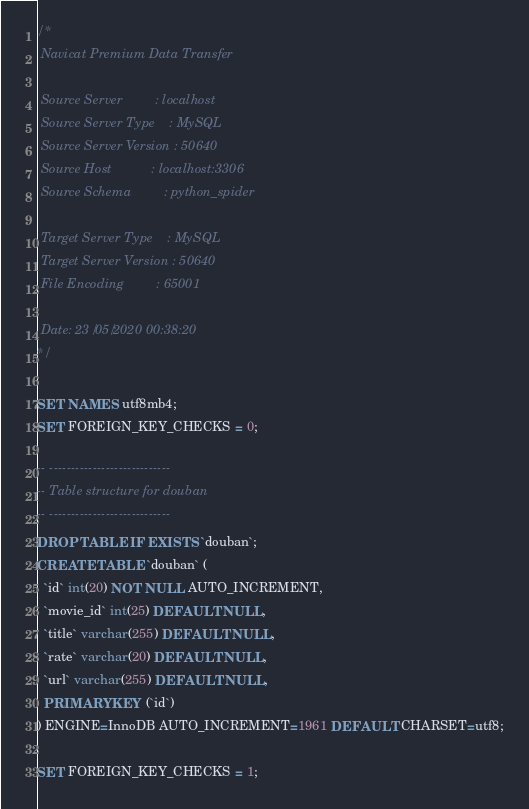Convert code to text. <code><loc_0><loc_0><loc_500><loc_500><_SQL_>/*
 Navicat Premium Data Transfer

 Source Server         : localhost
 Source Server Type    : MySQL
 Source Server Version : 50640
 Source Host           : localhost:3306
 Source Schema         : python_spider

 Target Server Type    : MySQL
 Target Server Version : 50640
 File Encoding         : 65001

 Date: 23/05/2020 00:38:20
*/

SET NAMES utf8mb4;
SET FOREIGN_KEY_CHECKS = 0;

-- ----------------------------
-- Table structure for douban
-- ----------------------------
DROP TABLE IF EXISTS `douban`;
CREATE TABLE `douban` (
  `id` int(20) NOT NULL AUTO_INCREMENT,
  `movie_id` int(25) DEFAULT NULL,
  `title` varchar(255) DEFAULT NULL,
  `rate` varchar(20) DEFAULT NULL,
  `url` varchar(255) DEFAULT NULL,
  PRIMARY KEY (`id`)
) ENGINE=InnoDB AUTO_INCREMENT=1961 DEFAULT CHARSET=utf8;

SET FOREIGN_KEY_CHECKS = 1;
</code> 